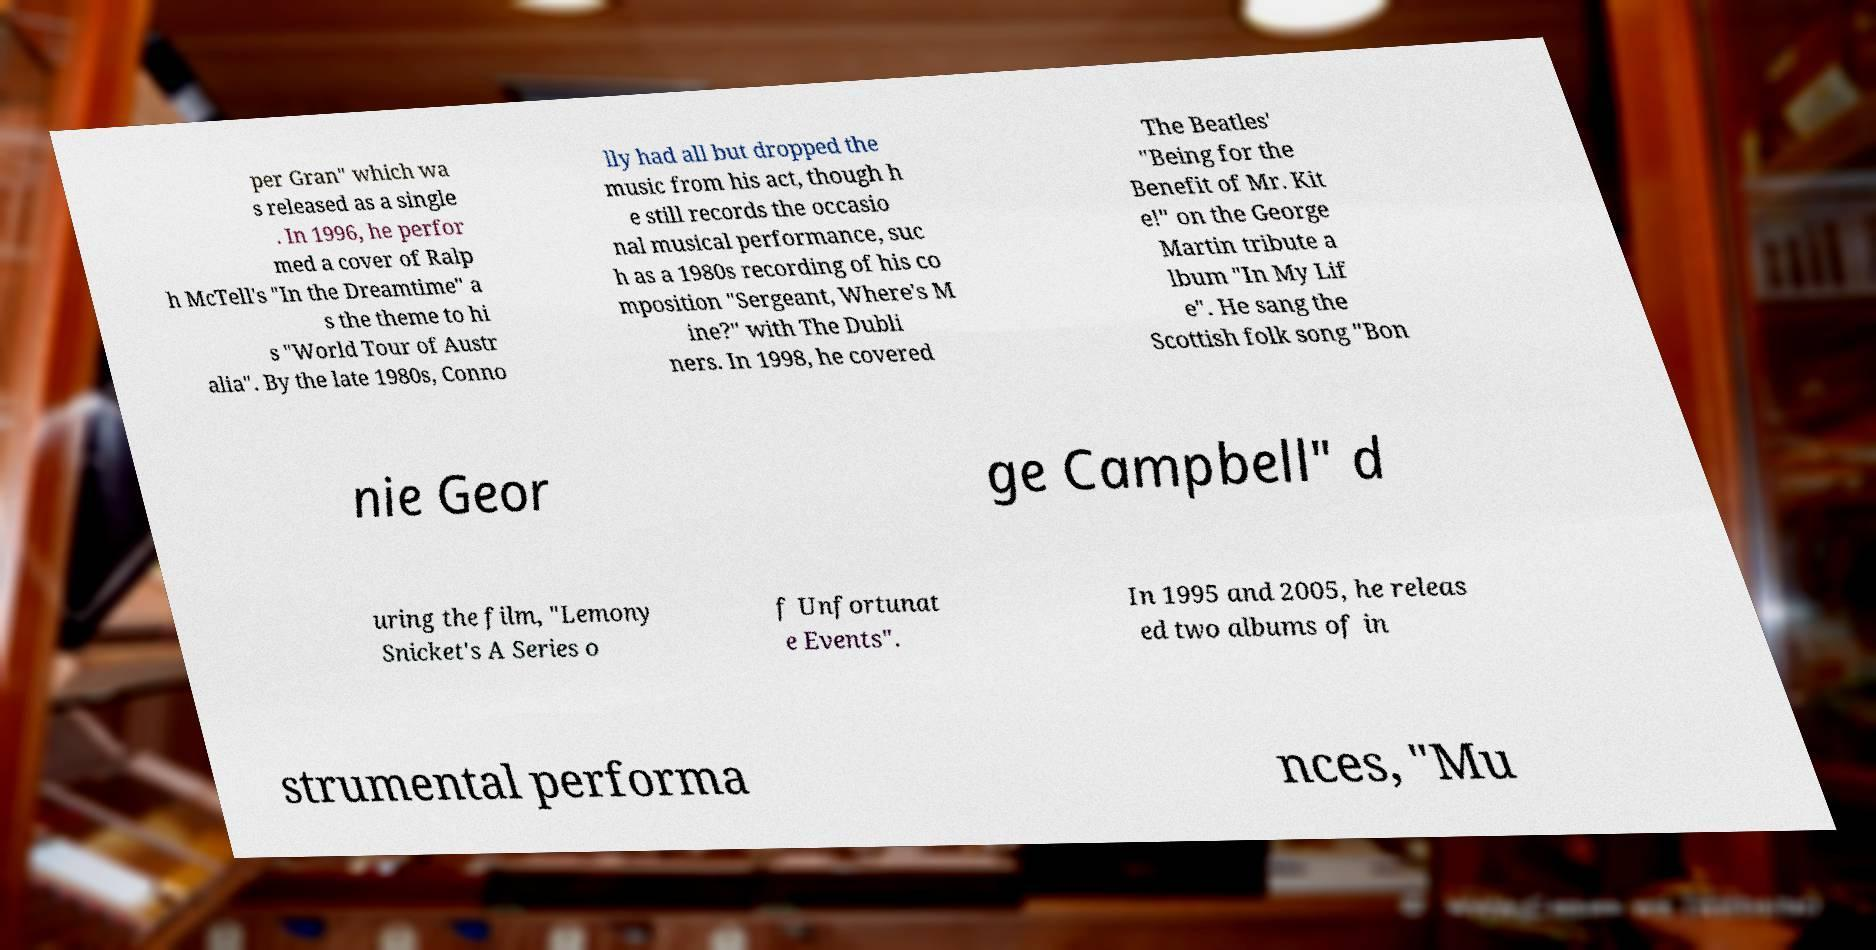Can you accurately transcribe the text from the provided image for me? per Gran" which wa s released as a single . In 1996, he perfor med a cover of Ralp h McTell's "In the Dreamtime" a s the theme to hi s "World Tour of Austr alia". By the late 1980s, Conno lly had all but dropped the music from his act, though h e still records the occasio nal musical performance, suc h as a 1980s recording of his co mposition "Sergeant, Where's M ine?" with The Dubli ners. In 1998, he covered The Beatles' "Being for the Benefit of Mr. Kit e!" on the George Martin tribute a lbum "In My Lif e". He sang the Scottish folk song "Bon nie Geor ge Campbell" d uring the film, "Lemony Snicket's A Series o f Unfortunat e Events". In 1995 and 2005, he releas ed two albums of in strumental performa nces, "Mu 